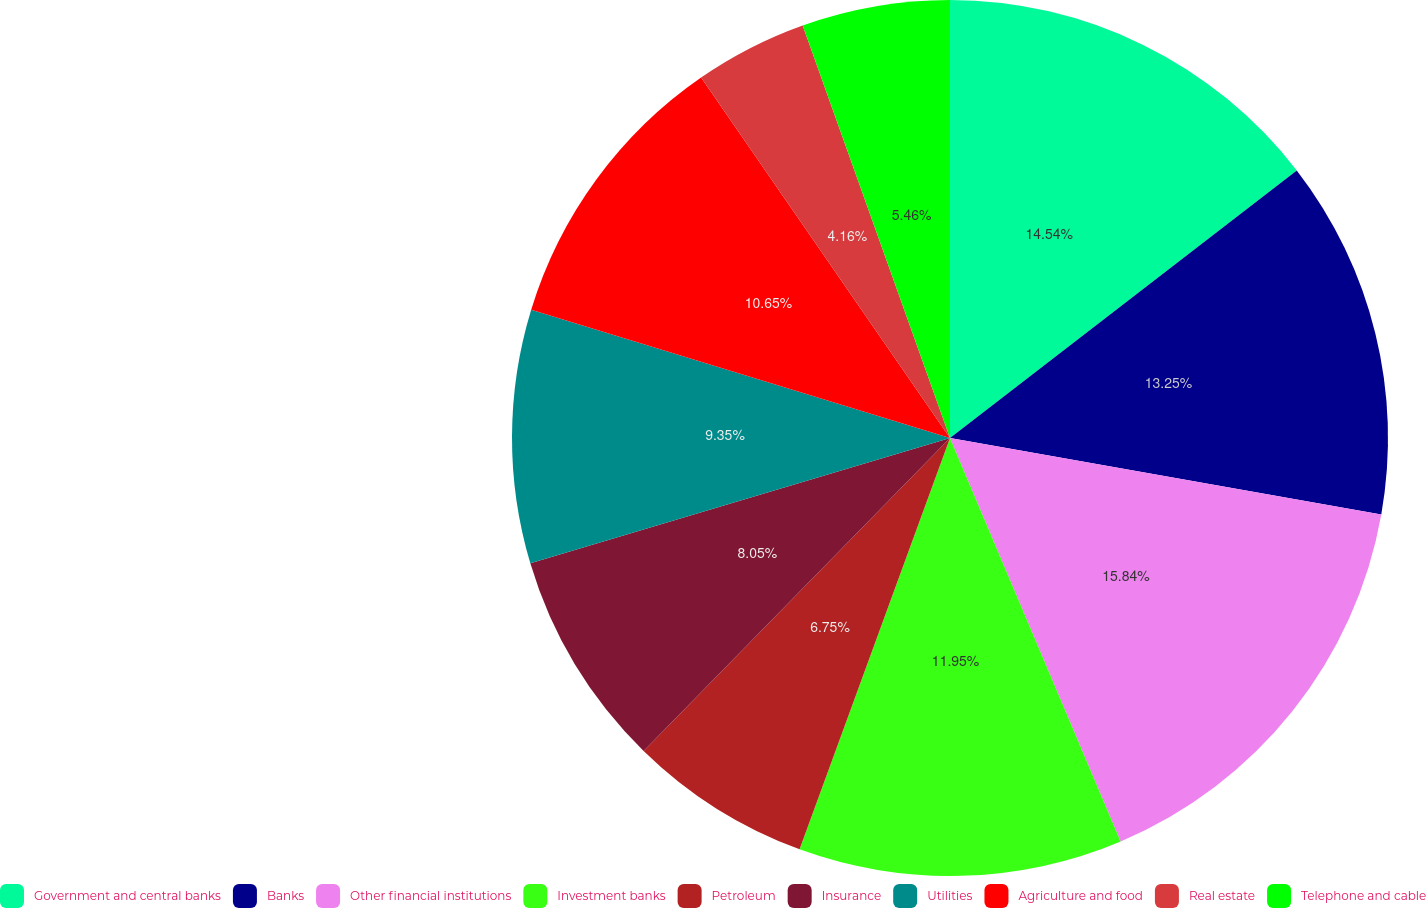Convert chart. <chart><loc_0><loc_0><loc_500><loc_500><pie_chart><fcel>Government and central banks<fcel>Banks<fcel>Other financial institutions<fcel>Investment banks<fcel>Petroleum<fcel>Insurance<fcel>Utilities<fcel>Agriculture and food<fcel>Real estate<fcel>Telephone and cable<nl><fcel>14.54%<fcel>13.25%<fcel>15.84%<fcel>11.95%<fcel>6.75%<fcel>8.05%<fcel>9.35%<fcel>10.65%<fcel>4.16%<fcel>5.46%<nl></chart> 